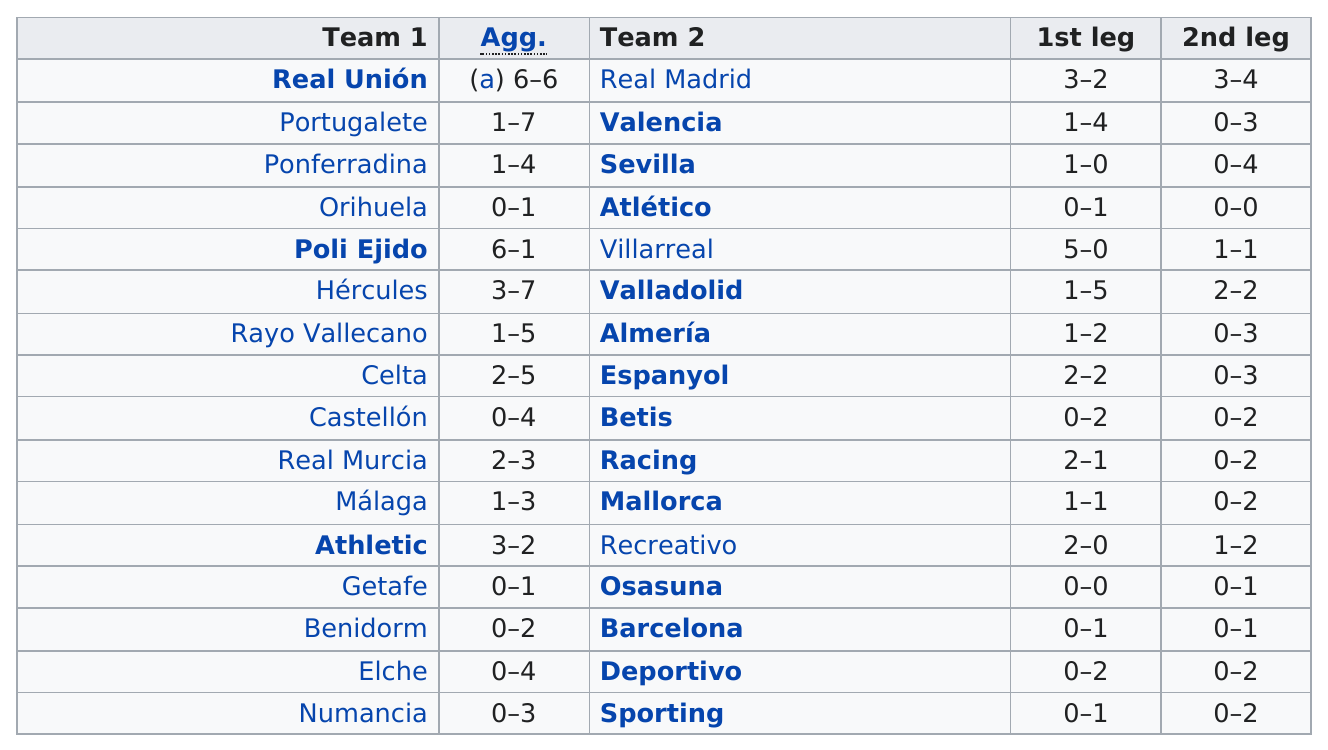List a handful of essential elements in this visual. In the first leg of the match, Poli Ejido was the top scorer. In the aggregate of Athletic and Recreativo, a total of 5 goals were scored. The aggregate number of goals in the Poli Ejido vs Villarreal series was 7. Valencia scored more than Portugalete. 